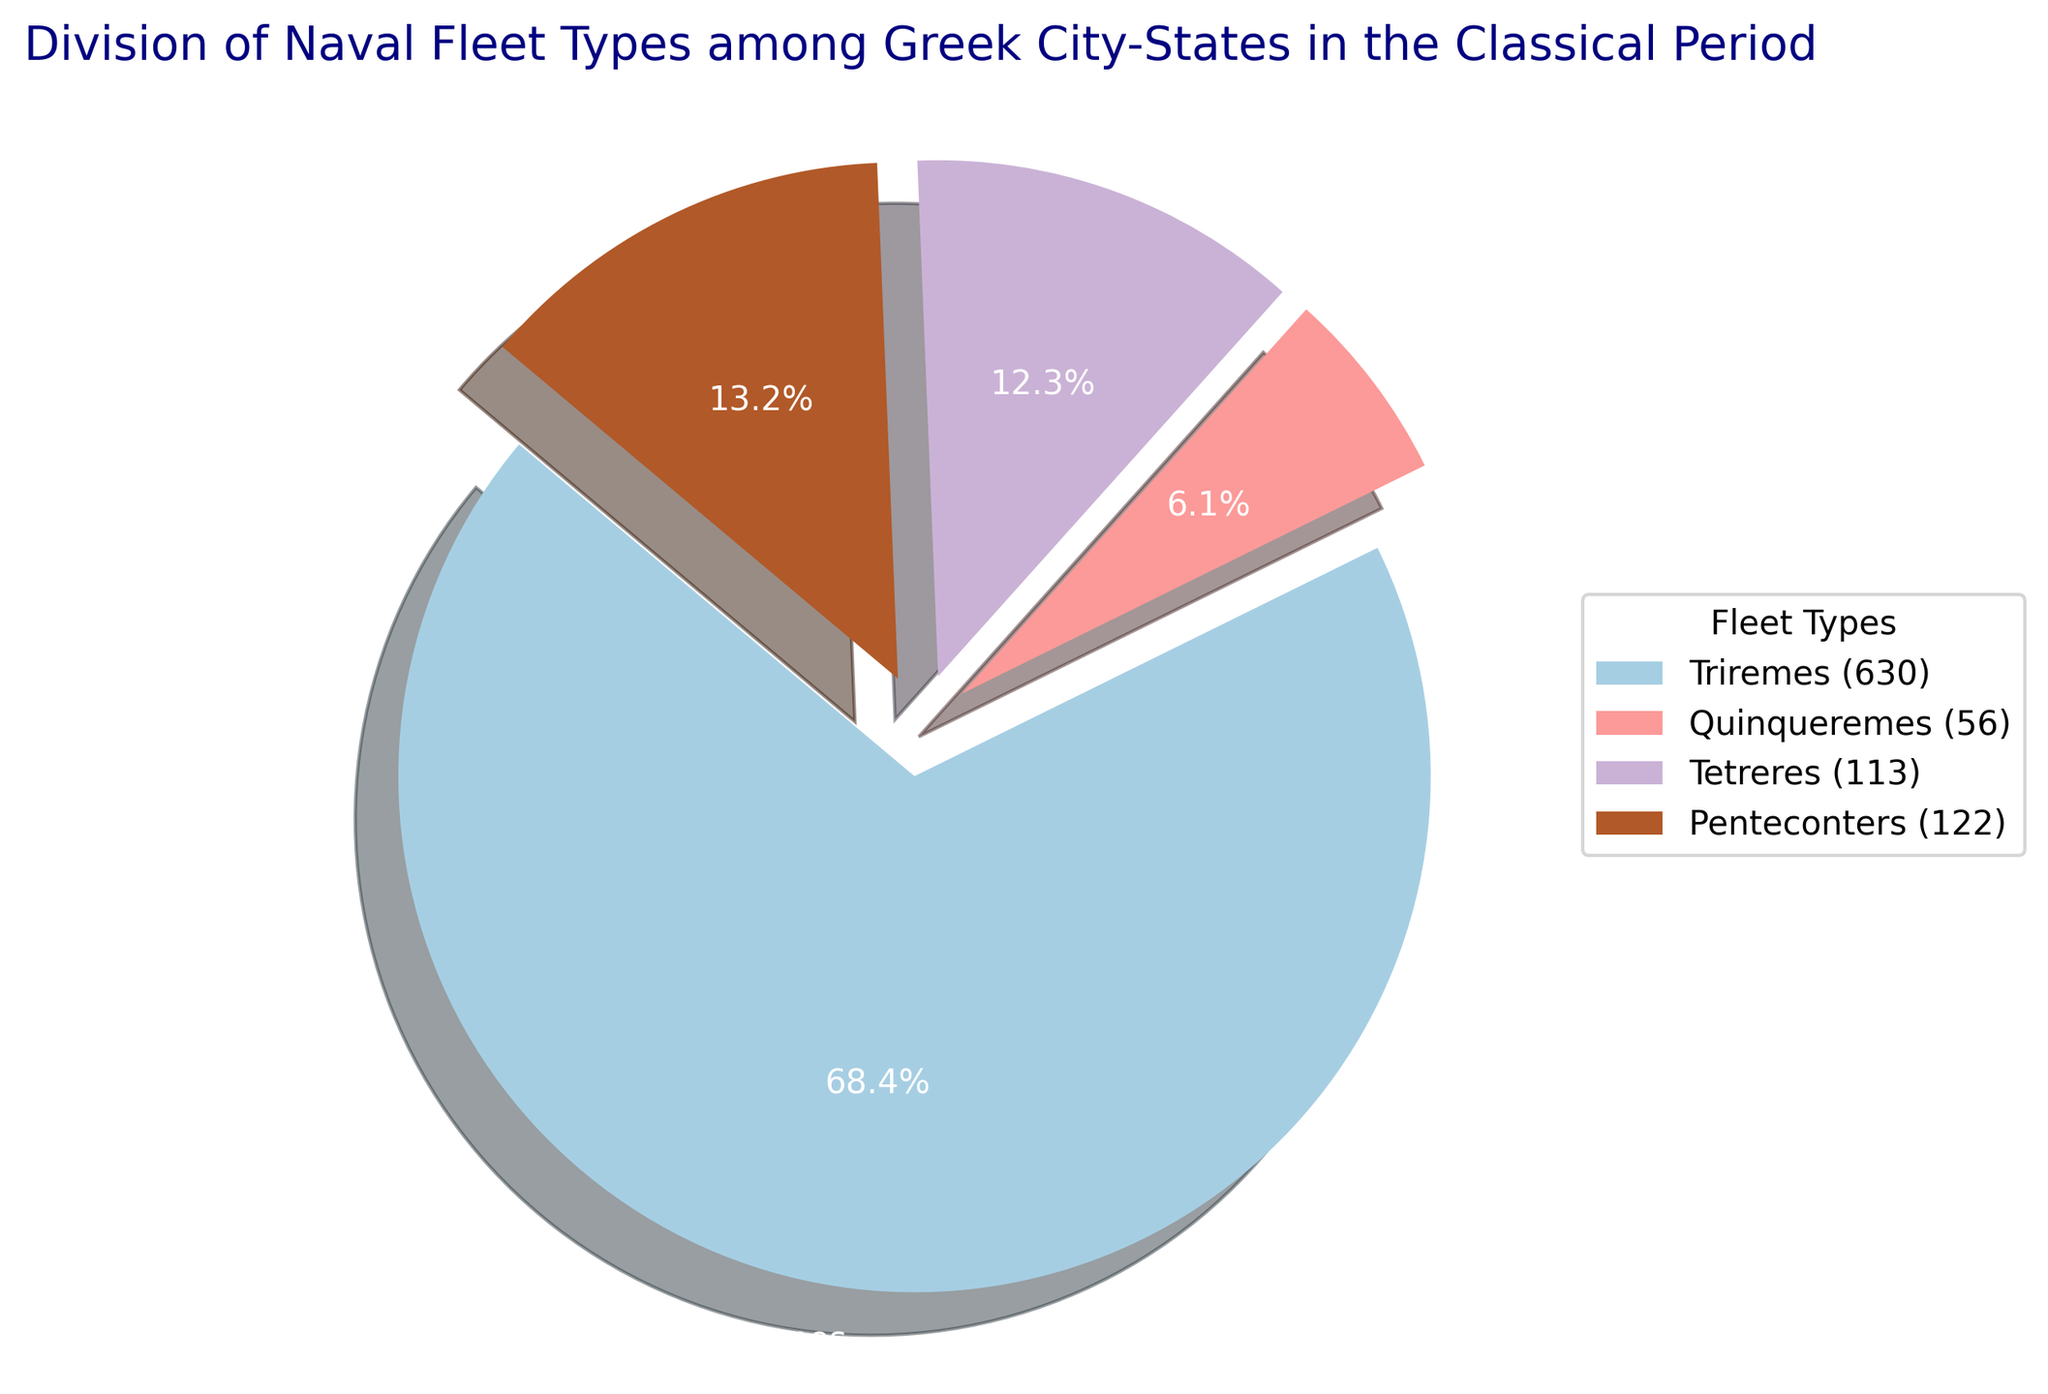What fleet type had the largest share of the total naval fleet composition? The largest share is represented by the biggest slice in the pie chart, which can be identified by size and percentage. Triremes have the largest share at 67.0%.
Answer: Triremes How many Quinqueremes are there in total? Refer to the legend on the pie chart which shows fleet types along with their respective counts. Quinqueremes have a total of 56.
Answer: 56 Which fleet type had the smallest share in the naval fleet composition? The smallest share is identified by the smallest slice in the pie chart. Quinqueremes have the smallest share at 8.6%.
Answer: Quinqueremes What is the combined percentage of Tetreres and Penteconters? Refer to the percentages noted on the slices for Tetreres and Penteconters. Tetreres have 15.5% and Penteconters have 8.9%. Adding these up, 15.5% + 8.9% = 24.4%.
Answer: 24.4% Is the percentage share of Penteconters greater than Quinqueremes? Compare the percentage values on the slices for Quinqueremes and Penteconters. Quinqueremes have 8.6% while Penteconters have 8.9%.
Answer: Yes How does the count of Triremes compare to the sum of Tetreres and Penteconters? The pie chart legend states there are 630 Triremes. The counts of Tetreres and Penteconters are 145 and 83, respectively. Adding these, 145 + 83 = 228. Triremes significantly outnumber this sum.
Answer: Greater Which fleet type has a slightly lesser share than Tetreres? Referring to the slices' percentage values, Quinqueremes at 8.6% is slightly lesser than Tetreres at 15.5%.
Answer: Quinqueremes What are the total counts for Triremes and Quinqueremes combined? Extract counts from the legend: 630 for Triremes and 56 for Quinqueremes. Adding these, 630 + 56 = 686.
Answer: 686 What color represents Tetreres in the pie chart? By visually identifying colors from the pie chart segments, Tetreres are often distinctively marked. In this case, Tetreres are shown in a middle-shaded color (probably light green).
Answer: Light green (or equivalent middle-shade color) 